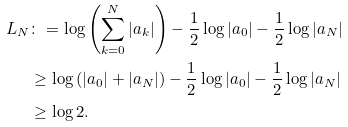Convert formula to latex. <formula><loc_0><loc_0><loc_500><loc_500>L _ { N } & \colon = \log \left ( \sum _ { k = 0 } ^ { N } | a _ { k } | \right ) - \frac { 1 } { 2 } \log | a _ { 0 } | - \frac { 1 } { 2 } \log | a _ { N } | \\ & \geq \log \left ( | a _ { 0 } | + | a _ { N } | \right ) - \frac { 1 } { 2 } \log | a _ { 0 } | - \frac { 1 } { 2 } \log | a _ { N } | \\ & \geq \log 2 .</formula> 